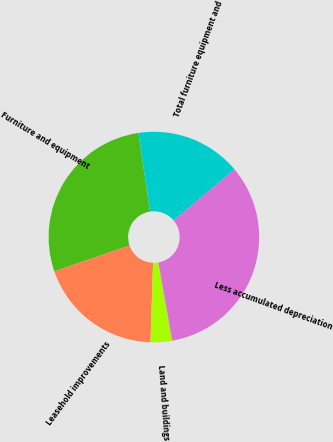Convert chart to OTSL. <chart><loc_0><loc_0><loc_500><loc_500><pie_chart><fcel>Furniture and equipment<fcel>Leasehold improvements<fcel>Land and buildings<fcel>Less accumulated depreciation<fcel>Total furniture equipment and<nl><fcel>27.93%<fcel>19.21%<fcel>3.29%<fcel>33.36%<fcel>16.21%<nl></chart> 